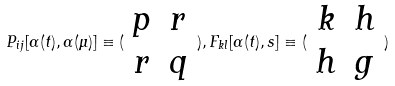Convert formula to latex. <formula><loc_0><loc_0><loc_500><loc_500>P _ { i j } [ \alpha ( t ) , \alpha ( \mu ) ] \equiv ( \begin{array} { c c } p & r \\ r & q \end{array} ) , F _ { k l } [ \alpha ( t ) , s ] \equiv ( \begin{array} { c c } k & h \\ h & g \end{array} )</formula> 